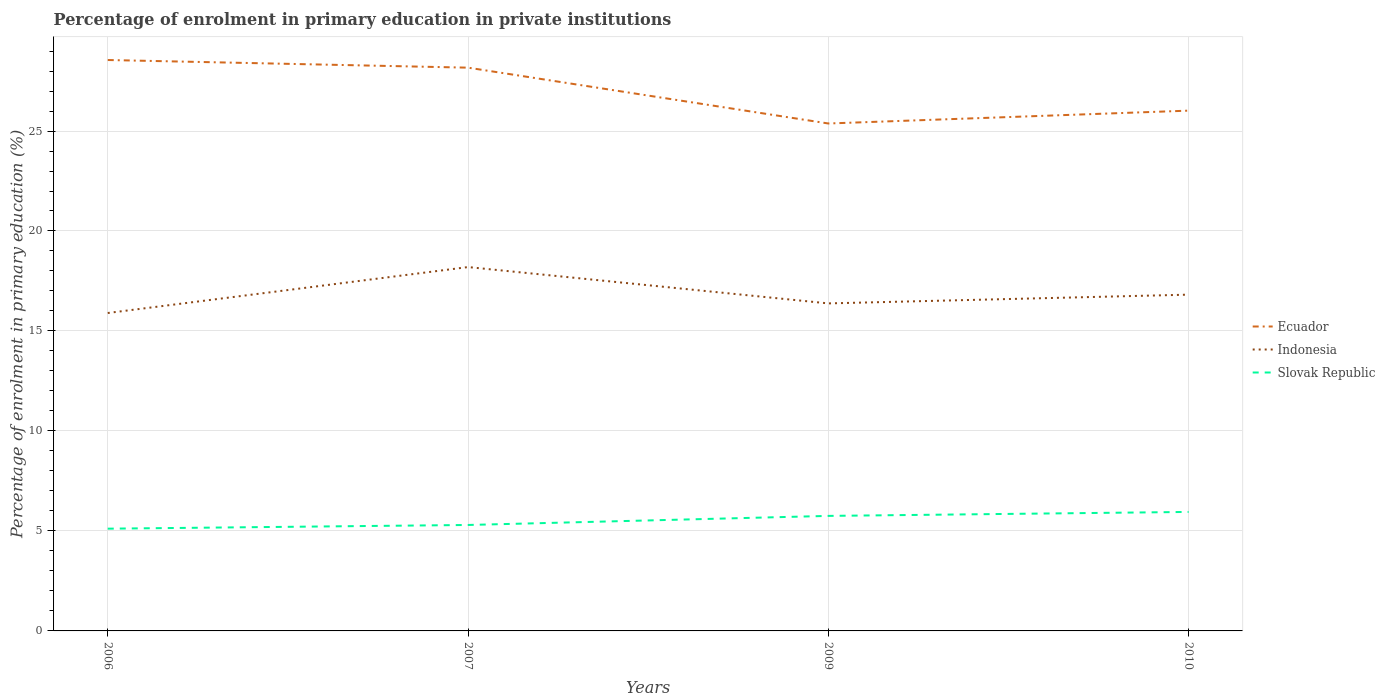How many different coloured lines are there?
Give a very brief answer. 3. Across all years, what is the maximum percentage of enrolment in primary education in Slovak Republic?
Provide a short and direct response. 5.11. What is the total percentage of enrolment in primary education in Indonesia in the graph?
Offer a very short reply. -0.92. What is the difference between the highest and the second highest percentage of enrolment in primary education in Indonesia?
Your answer should be very brief. 2.3. Is the percentage of enrolment in primary education in Ecuador strictly greater than the percentage of enrolment in primary education in Slovak Republic over the years?
Make the answer very short. No. What is the difference between two consecutive major ticks on the Y-axis?
Ensure brevity in your answer.  5. Where does the legend appear in the graph?
Your answer should be compact. Center right. How are the legend labels stacked?
Your answer should be compact. Vertical. What is the title of the graph?
Offer a terse response. Percentage of enrolment in primary education in private institutions. What is the label or title of the Y-axis?
Make the answer very short. Percentage of enrolment in primary education (%). What is the Percentage of enrolment in primary education (%) of Ecuador in 2006?
Provide a short and direct response. 28.55. What is the Percentage of enrolment in primary education (%) of Indonesia in 2006?
Provide a short and direct response. 15.9. What is the Percentage of enrolment in primary education (%) of Slovak Republic in 2006?
Offer a very short reply. 5.11. What is the Percentage of enrolment in primary education (%) of Ecuador in 2007?
Make the answer very short. 28.17. What is the Percentage of enrolment in primary education (%) of Indonesia in 2007?
Offer a very short reply. 18.2. What is the Percentage of enrolment in primary education (%) in Slovak Republic in 2007?
Your answer should be compact. 5.3. What is the Percentage of enrolment in primary education (%) in Ecuador in 2009?
Provide a succinct answer. 25.38. What is the Percentage of enrolment in primary education (%) of Indonesia in 2009?
Make the answer very short. 16.38. What is the Percentage of enrolment in primary education (%) of Slovak Republic in 2009?
Give a very brief answer. 5.75. What is the Percentage of enrolment in primary education (%) in Ecuador in 2010?
Give a very brief answer. 26.02. What is the Percentage of enrolment in primary education (%) in Indonesia in 2010?
Provide a short and direct response. 16.82. What is the Percentage of enrolment in primary education (%) of Slovak Republic in 2010?
Provide a succinct answer. 5.95. Across all years, what is the maximum Percentage of enrolment in primary education (%) in Ecuador?
Ensure brevity in your answer.  28.55. Across all years, what is the maximum Percentage of enrolment in primary education (%) in Indonesia?
Provide a short and direct response. 18.2. Across all years, what is the maximum Percentage of enrolment in primary education (%) of Slovak Republic?
Provide a succinct answer. 5.95. Across all years, what is the minimum Percentage of enrolment in primary education (%) in Ecuador?
Your response must be concise. 25.38. Across all years, what is the minimum Percentage of enrolment in primary education (%) of Indonesia?
Your answer should be very brief. 15.9. Across all years, what is the minimum Percentage of enrolment in primary education (%) of Slovak Republic?
Offer a terse response. 5.11. What is the total Percentage of enrolment in primary education (%) in Ecuador in the graph?
Provide a succinct answer. 108.11. What is the total Percentage of enrolment in primary education (%) in Indonesia in the graph?
Ensure brevity in your answer.  67.29. What is the total Percentage of enrolment in primary education (%) in Slovak Republic in the graph?
Ensure brevity in your answer.  22.12. What is the difference between the Percentage of enrolment in primary education (%) in Ecuador in 2006 and that in 2007?
Provide a short and direct response. 0.38. What is the difference between the Percentage of enrolment in primary education (%) in Indonesia in 2006 and that in 2007?
Make the answer very short. -2.3. What is the difference between the Percentage of enrolment in primary education (%) in Slovak Republic in 2006 and that in 2007?
Provide a short and direct response. -0.18. What is the difference between the Percentage of enrolment in primary education (%) in Ecuador in 2006 and that in 2009?
Your answer should be very brief. 3.17. What is the difference between the Percentage of enrolment in primary education (%) of Indonesia in 2006 and that in 2009?
Ensure brevity in your answer.  -0.48. What is the difference between the Percentage of enrolment in primary education (%) in Slovak Republic in 2006 and that in 2009?
Give a very brief answer. -0.64. What is the difference between the Percentage of enrolment in primary education (%) of Ecuador in 2006 and that in 2010?
Provide a short and direct response. 2.53. What is the difference between the Percentage of enrolment in primary education (%) of Indonesia in 2006 and that in 2010?
Your answer should be very brief. -0.92. What is the difference between the Percentage of enrolment in primary education (%) in Slovak Republic in 2006 and that in 2010?
Provide a short and direct response. -0.84. What is the difference between the Percentage of enrolment in primary education (%) of Ecuador in 2007 and that in 2009?
Your answer should be compact. 2.79. What is the difference between the Percentage of enrolment in primary education (%) in Indonesia in 2007 and that in 2009?
Your answer should be very brief. 1.82. What is the difference between the Percentage of enrolment in primary education (%) in Slovak Republic in 2007 and that in 2009?
Keep it short and to the point. -0.45. What is the difference between the Percentage of enrolment in primary education (%) of Ecuador in 2007 and that in 2010?
Provide a short and direct response. 2.15. What is the difference between the Percentage of enrolment in primary education (%) in Indonesia in 2007 and that in 2010?
Your answer should be very brief. 1.38. What is the difference between the Percentage of enrolment in primary education (%) in Slovak Republic in 2007 and that in 2010?
Offer a terse response. -0.65. What is the difference between the Percentage of enrolment in primary education (%) in Ecuador in 2009 and that in 2010?
Provide a short and direct response. -0.64. What is the difference between the Percentage of enrolment in primary education (%) of Indonesia in 2009 and that in 2010?
Keep it short and to the point. -0.44. What is the difference between the Percentage of enrolment in primary education (%) of Slovak Republic in 2009 and that in 2010?
Offer a terse response. -0.2. What is the difference between the Percentage of enrolment in primary education (%) of Ecuador in 2006 and the Percentage of enrolment in primary education (%) of Indonesia in 2007?
Ensure brevity in your answer.  10.35. What is the difference between the Percentage of enrolment in primary education (%) in Ecuador in 2006 and the Percentage of enrolment in primary education (%) in Slovak Republic in 2007?
Give a very brief answer. 23.25. What is the difference between the Percentage of enrolment in primary education (%) of Indonesia in 2006 and the Percentage of enrolment in primary education (%) of Slovak Republic in 2007?
Provide a succinct answer. 10.6. What is the difference between the Percentage of enrolment in primary education (%) of Ecuador in 2006 and the Percentage of enrolment in primary education (%) of Indonesia in 2009?
Your answer should be compact. 12.17. What is the difference between the Percentage of enrolment in primary education (%) in Ecuador in 2006 and the Percentage of enrolment in primary education (%) in Slovak Republic in 2009?
Your answer should be very brief. 22.8. What is the difference between the Percentage of enrolment in primary education (%) in Indonesia in 2006 and the Percentage of enrolment in primary education (%) in Slovak Republic in 2009?
Provide a succinct answer. 10.15. What is the difference between the Percentage of enrolment in primary education (%) in Ecuador in 2006 and the Percentage of enrolment in primary education (%) in Indonesia in 2010?
Ensure brevity in your answer.  11.73. What is the difference between the Percentage of enrolment in primary education (%) in Ecuador in 2006 and the Percentage of enrolment in primary education (%) in Slovak Republic in 2010?
Your answer should be very brief. 22.6. What is the difference between the Percentage of enrolment in primary education (%) in Indonesia in 2006 and the Percentage of enrolment in primary education (%) in Slovak Republic in 2010?
Your answer should be very brief. 9.95. What is the difference between the Percentage of enrolment in primary education (%) of Ecuador in 2007 and the Percentage of enrolment in primary education (%) of Indonesia in 2009?
Offer a terse response. 11.79. What is the difference between the Percentage of enrolment in primary education (%) in Ecuador in 2007 and the Percentage of enrolment in primary education (%) in Slovak Republic in 2009?
Your answer should be very brief. 22.42. What is the difference between the Percentage of enrolment in primary education (%) of Indonesia in 2007 and the Percentage of enrolment in primary education (%) of Slovak Republic in 2009?
Your response must be concise. 12.44. What is the difference between the Percentage of enrolment in primary education (%) in Ecuador in 2007 and the Percentage of enrolment in primary education (%) in Indonesia in 2010?
Give a very brief answer. 11.35. What is the difference between the Percentage of enrolment in primary education (%) in Ecuador in 2007 and the Percentage of enrolment in primary education (%) in Slovak Republic in 2010?
Give a very brief answer. 22.22. What is the difference between the Percentage of enrolment in primary education (%) in Indonesia in 2007 and the Percentage of enrolment in primary education (%) in Slovak Republic in 2010?
Give a very brief answer. 12.25. What is the difference between the Percentage of enrolment in primary education (%) of Ecuador in 2009 and the Percentage of enrolment in primary education (%) of Indonesia in 2010?
Provide a succinct answer. 8.56. What is the difference between the Percentage of enrolment in primary education (%) in Ecuador in 2009 and the Percentage of enrolment in primary education (%) in Slovak Republic in 2010?
Your response must be concise. 19.43. What is the difference between the Percentage of enrolment in primary education (%) in Indonesia in 2009 and the Percentage of enrolment in primary education (%) in Slovak Republic in 2010?
Your answer should be compact. 10.43. What is the average Percentage of enrolment in primary education (%) of Ecuador per year?
Offer a terse response. 27.03. What is the average Percentage of enrolment in primary education (%) of Indonesia per year?
Your answer should be compact. 16.82. What is the average Percentage of enrolment in primary education (%) in Slovak Republic per year?
Your answer should be compact. 5.53. In the year 2006, what is the difference between the Percentage of enrolment in primary education (%) of Ecuador and Percentage of enrolment in primary education (%) of Indonesia?
Keep it short and to the point. 12.65. In the year 2006, what is the difference between the Percentage of enrolment in primary education (%) of Ecuador and Percentage of enrolment in primary education (%) of Slovak Republic?
Offer a very short reply. 23.44. In the year 2006, what is the difference between the Percentage of enrolment in primary education (%) of Indonesia and Percentage of enrolment in primary education (%) of Slovak Republic?
Your answer should be compact. 10.79. In the year 2007, what is the difference between the Percentage of enrolment in primary education (%) of Ecuador and Percentage of enrolment in primary education (%) of Indonesia?
Keep it short and to the point. 9.97. In the year 2007, what is the difference between the Percentage of enrolment in primary education (%) of Ecuador and Percentage of enrolment in primary education (%) of Slovak Republic?
Your response must be concise. 22.87. In the year 2007, what is the difference between the Percentage of enrolment in primary education (%) in Indonesia and Percentage of enrolment in primary education (%) in Slovak Republic?
Offer a very short reply. 12.9. In the year 2009, what is the difference between the Percentage of enrolment in primary education (%) of Ecuador and Percentage of enrolment in primary education (%) of Indonesia?
Give a very brief answer. 9. In the year 2009, what is the difference between the Percentage of enrolment in primary education (%) of Ecuador and Percentage of enrolment in primary education (%) of Slovak Republic?
Keep it short and to the point. 19.62. In the year 2009, what is the difference between the Percentage of enrolment in primary education (%) of Indonesia and Percentage of enrolment in primary education (%) of Slovak Republic?
Ensure brevity in your answer.  10.63. In the year 2010, what is the difference between the Percentage of enrolment in primary education (%) of Ecuador and Percentage of enrolment in primary education (%) of Indonesia?
Keep it short and to the point. 9.2. In the year 2010, what is the difference between the Percentage of enrolment in primary education (%) of Ecuador and Percentage of enrolment in primary education (%) of Slovak Republic?
Your answer should be very brief. 20.07. In the year 2010, what is the difference between the Percentage of enrolment in primary education (%) in Indonesia and Percentage of enrolment in primary education (%) in Slovak Republic?
Ensure brevity in your answer.  10.87. What is the ratio of the Percentage of enrolment in primary education (%) in Ecuador in 2006 to that in 2007?
Ensure brevity in your answer.  1.01. What is the ratio of the Percentage of enrolment in primary education (%) in Indonesia in 2006 to that in 2007?
Offer a terse response. 0.87. What is the ratio of the Percentage of enrolment in primary education (%) in Slovak Republic in 2006 to that in 2007?
Ensure brevity in your answer.  0.97. What is the ratio of the Percentage of enrolment in primary education (%) of Ecuador in 2006 to that in 2009?
Your response must be concise. 1.13. What is the ratio of the Percentage of enrolment in primary education (%) of Indonesia in 2006 to that in 2009?
Make the answer very short. 0.97. What is the ratio of the Percentage of enrolment in primary education (%) of Ecuador in 2006 to that in 2010?
Provide a succinct answer. 1.1. What is the ratio of the Percentage of enrolment in primary education (%) in Indonesia in 2006 to that in 2010?
Offer a very short reply. 0.95. What is the ratio of the Percentage of enrolment in primary education (%) of Slovak Republic in 2006 to that in 2010?
Ensure brevity in your answer.  0.86. What is the ratio of the Percentage of enrolment in primary education (%) in Ecuador in 2007 to that in 2009?
Your answer should be compact. 1.11. What is the ratio of the Percentage of enrolment in primary education (%) in Indonesia in 2007 to that in 2009?
Your answer should be very brief. 1.11. What is the ratio of the Percentage of enrolment in primary education (%) of Slovak Republic in 2007 to that in 2009?
Your response must be concise. 0.92. What is the ratio of the Percentage of enrolment in primary education (%) of Ecuador in 2007 to that in 2010?
Keep it short and to the point. 1.08. What is the ratio of the Percentage of enrolment in primary education (%) in Indonesia in 2007 to that in 2010?
Offer a terse response. 1.08. What is the ratio of the Percentage of enrolment in primary education (%) of Slovak Republic in 2007 to that in 2010?
Give a very brief answer. 0.89. What is the ratio of the Percentage of enrolment in primary education (%) of Ecuador in 2009 to that in 2010?
Provide a succinct answer. 0.98. What is the ratio of the Percentage of enrolment in primary education (%) of Slovak Republic in 2009 to that in 2010?
Offer a very short reply. 0.97. What is the difference between the highest and the second highest Percentage of enrolment in primary education (%) in Ecuador?
Your answer should be very brief. 0.38. What is the difference between the highest and the second highest Percentage of enrolment in primary education (%) of Indonesia?
Provide a short and direct response. 1.38. What is the difference between the highest and the second highest Percentage of enrolment in primary education (%) in Slovak Republic?
Offer a terse response. 0.2. What is the difference between the highest and the lowest Percentage of enrolment in primary education (%) in Ecuador?
Offer a very short reply. 3.17. What is the difference between the highest and the lowest Percentage of enrolment in primary education (%) in Indonesia?
Keep it short and to the point. 2.3. What is the difference between the highest and the lowest Percentage of enrolment in primary education (%) in Slovak Republic?
Your answer should be compact. 0.84. 